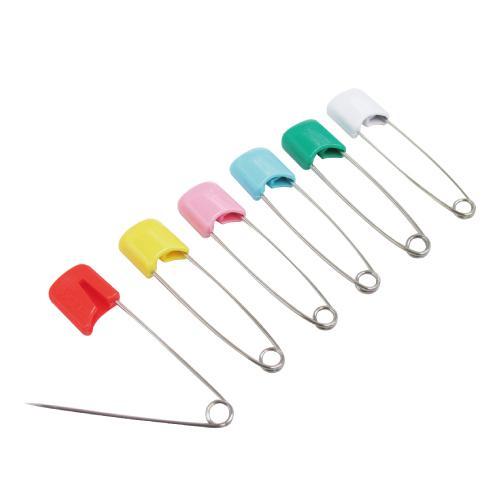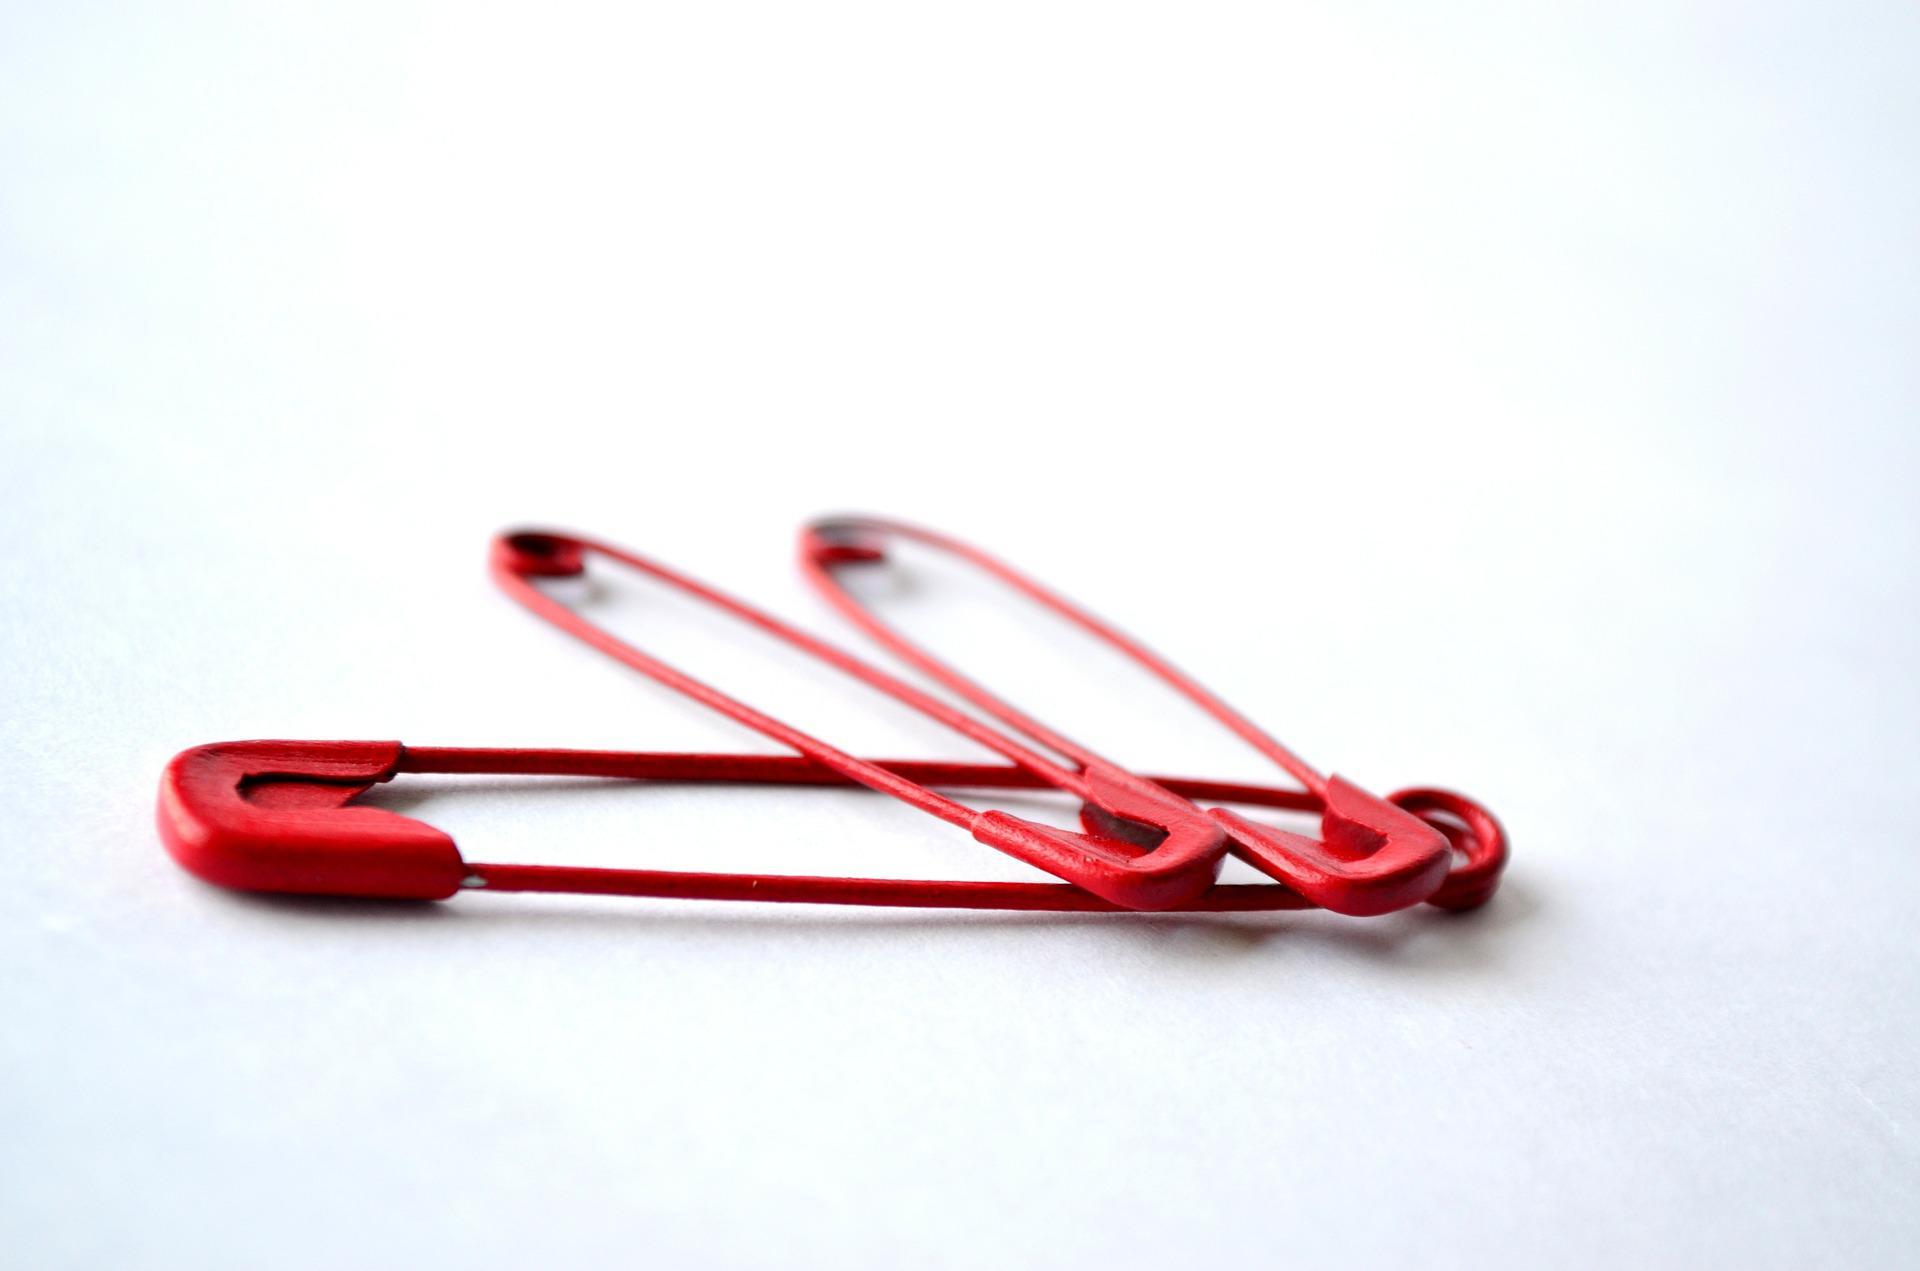The first image is the image on the left, the second image is the image on the right. Assess this claim about the two images: "One of the images contains a row of safety pins and only one is open.". Correct or not? Answer yes or no. Yes. The first image is the image on the left, the second image is the image on the right. Evaluate the accuracy of this statement regarding the images: "One image shows a row of six safety pins, each with a different color top, and with one of the pins open on the end". Is it true? Answer yes or no. Yes. 